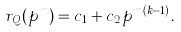<formula> <loc_0><loc_0><loc_500><loc_500>r _ { Q } ( p ^ { m } ) = c _ { 1 } + c _ { 2 } p ^ { m ( k - 1 ) } .</formula> 